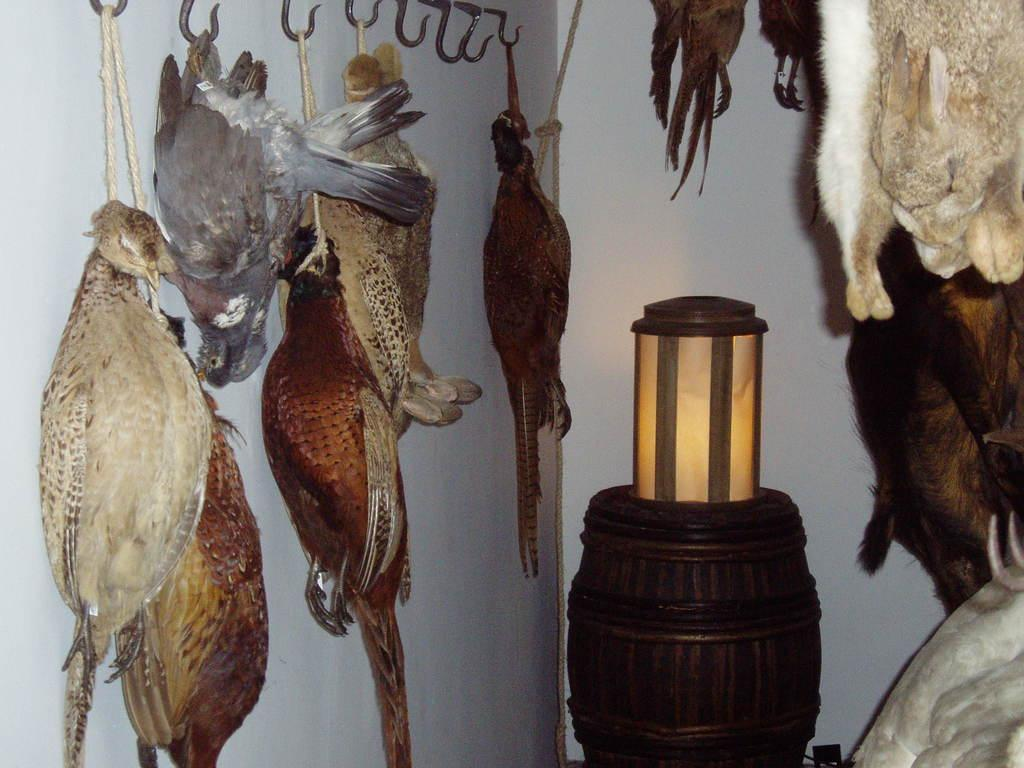What can be seen hanging on the left side of the image? There are birds hung on a hook stand on the left side of the image. What musical instrument is present in the image? There is a wooden drum in the image. What is placed on top of the wooden drum? A lamp is placed on the wooden drum. What can be seen hanging on the right side of the image? There are animals hung on the right side of the image. What type of polish is used to shine the wooden drum in the image? There is no mention of polish or any indication that the wooden drum has been polished in the image. What color is the marble used to create the animals on the right side of the image? There are no marble animals present in the image; the animals are hung and not made of marble. 